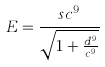Convert formula to latex. <formula><loc_0><loc_0><loc_500><loc_500>E = \frac { s c ^ { 9 } } { \sqrt { 1 + \frac { d ^ { 9 } } { c ^ { 9 } } } }</formula> 